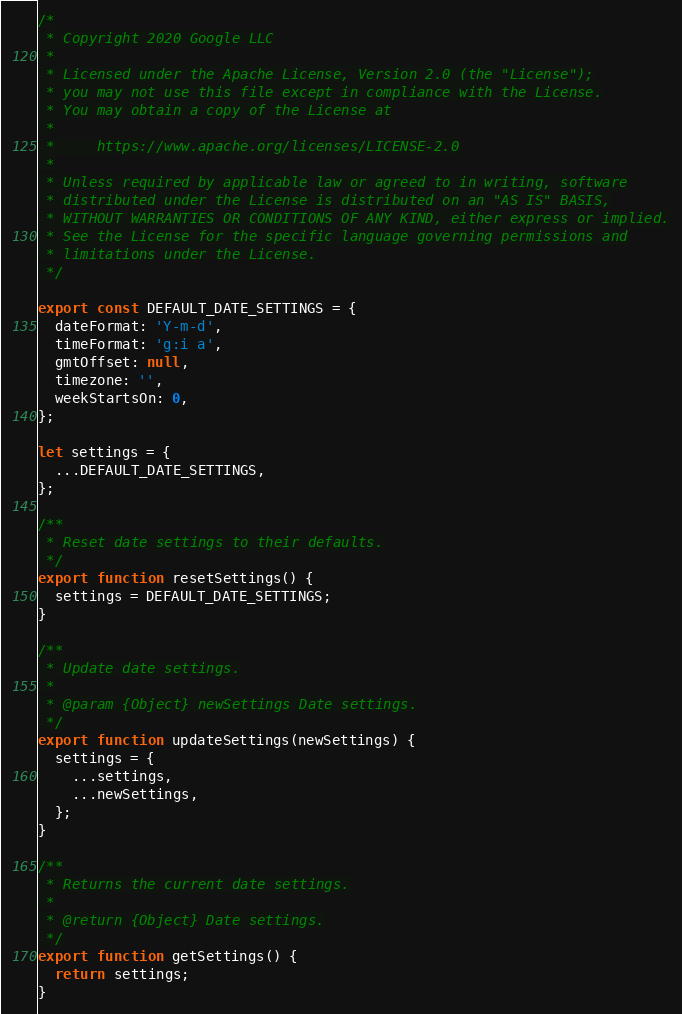<code> <loc_0><loc_0><loc_500><loc_500><_JavaScript_>/*
 * Copyright 2020 Google LLC
 *
 * Licensed under the Apache License, Version 2.0 (the "License");
 * you may not use this file except in compliance with the License.
 * You may obtain a copy of the License at
 *
 *     https://www.apache.org/licenses/LICENSE-2.0
 *
 * Unless required by applicable law or agreed to in writing, software
 * distributed under the License is distributed on an "AS IS" BASIS,
 * WITHOUT WARRANTIES OR CONDITIONS OF ANY KIND, either express or implied.
 * See the License for the specific language governing permissions and
 * limitations under the License.
 */

export const DEFAULT_DATE_SETTINGS = {
  dateFormat: 'Y-m-d',
  timeFormat: 'g:i a',
  gmtOffset: null,
  timezone: '',
  weekStartsOn: 0,
};

let settings = {
  ...DEFAULT_DATE_SETTINGS,
};

/**
 * Reset date settings to their defaults.
 */
export function resetSettings() {
  settings = DEFAULT_DATE_SETTINGS;
}

/**
 * Update date settings.
 *
 * @param {Object} newSettings Date settings.
 */
export function updateSettings(newSettings) {
  settings = {
    ...settings,
    ...newSettings,
  };
}

/**
 * Returns the current date settings.
 *
 * @return {Object} Date settings.
 */
export function getSettings() {
  return settings;
}
</code> 